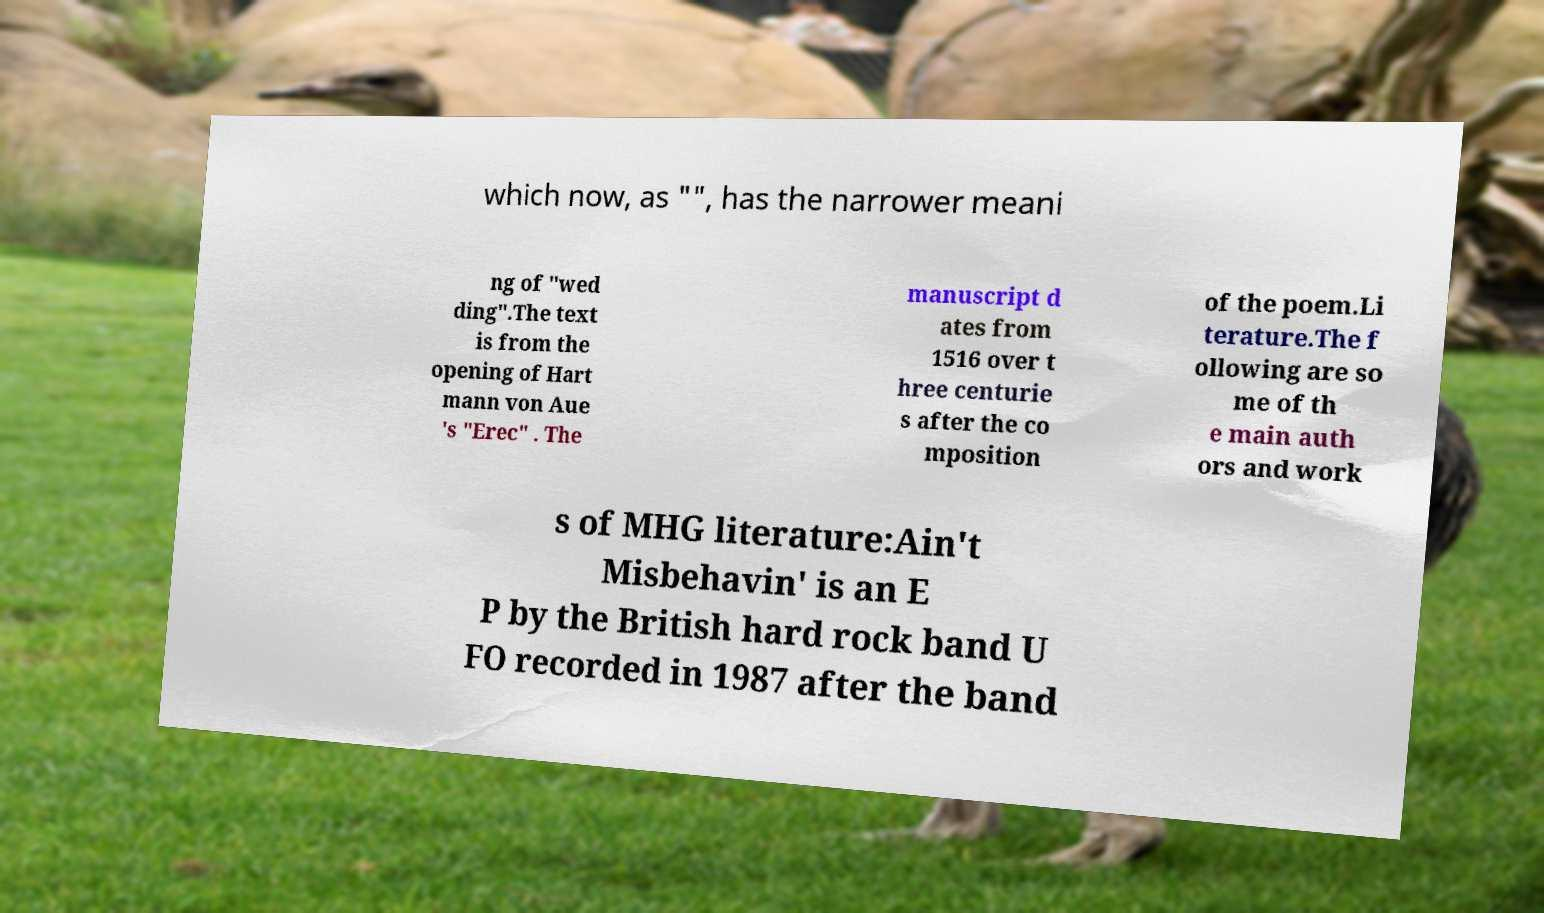For documentation purposes, I need the text within this image transcribed. Could you provide that? which now, as "", has the narrower meani ng of "wed ding".The text is from the opening of Hart mann von Aue 's "Erec" . The manuscript d ates from 1516 over t hree centurie s after the co mposition of the poem.Li terature.The f ollowing are so me of th e main auth ors and work s of MHG literature:Ain't Misbehavin' is an E P by the British hard rock band U FO recorded in 1987 after the band 